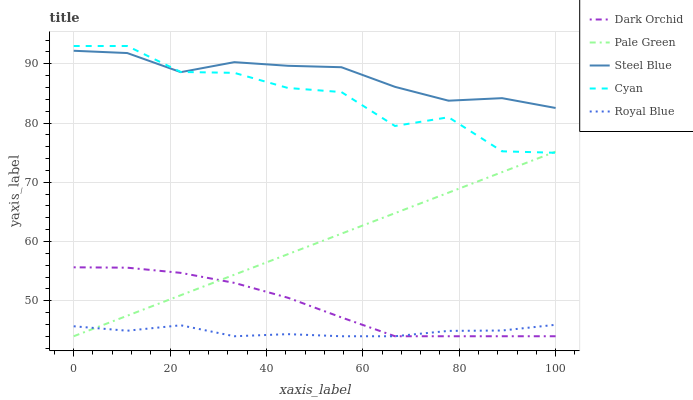Does Royal Blue have the minimum area under the curve?
Answer yes or no. Yes. Does Steel Blue have the maximum area under the curve?
Answer yes or no. Yes. Does Pale Green have the minimum area under the curve?
Answer yes or no. No. Does Pale Green have the maximum area under the curve?
Answer yes or no. No. Is Pale Green the smoothest?
Answer yes or no. Yes. Is Cyan the roughest?
Answer yes or no. Yes. Is Steel Blue the smoothest?
Answer yes or no. No. Is Steel Blue the roughest?
Answer yes or no. No. Does Pale Green have the lowest value?
Answer yes or no. Yes. Does Steel Blue have the lowest value?
Answer yes or no. No. Does Cyan have the highest value?
Answer yes or no. Yes. Does Pale Green have the highest value?
Answer yes or no. No. Is Dark Orchid less than Steel Blue?
Answer yes or no. Yes. Is Cyan greater than Royal Blue?
Answer yes or no. Yes. Does Dark Orchid intersect Royal Blue?
Answer yes or no. Yes. Is Dark Orchid less than Royal Blue?
Answer yes or no. No. Is Dark Orchid greater than Royal Blue?
Answer yes or no. No. Does Dark Orchid intersect Steel Blue?
Answer yes or no. No. 